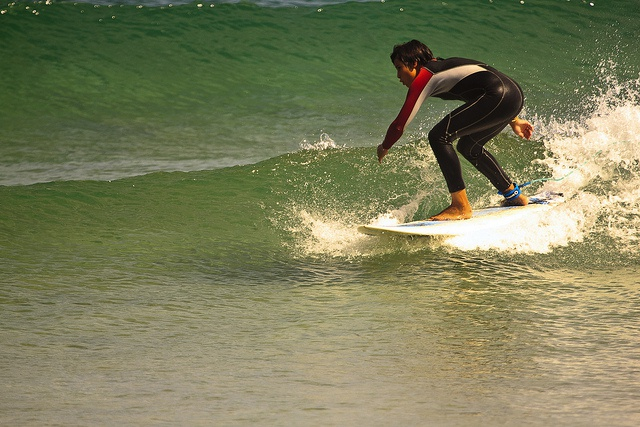Describe the objects in this image and their specific colors. I can see people in darkgreen, black, maroon, and gray tones and surfboard in darkgreen, ivory, khaki, and olive tones in this image. 